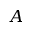<formula> <loc_0><loc_0><loc_500><loc_500>A</formula> 